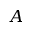<formula> <loc_0><loc_0><loc_500><loc_500>A</formula> 